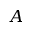<formula> <loc_0><loc_0><loc_500><loc_500>A</formula> 